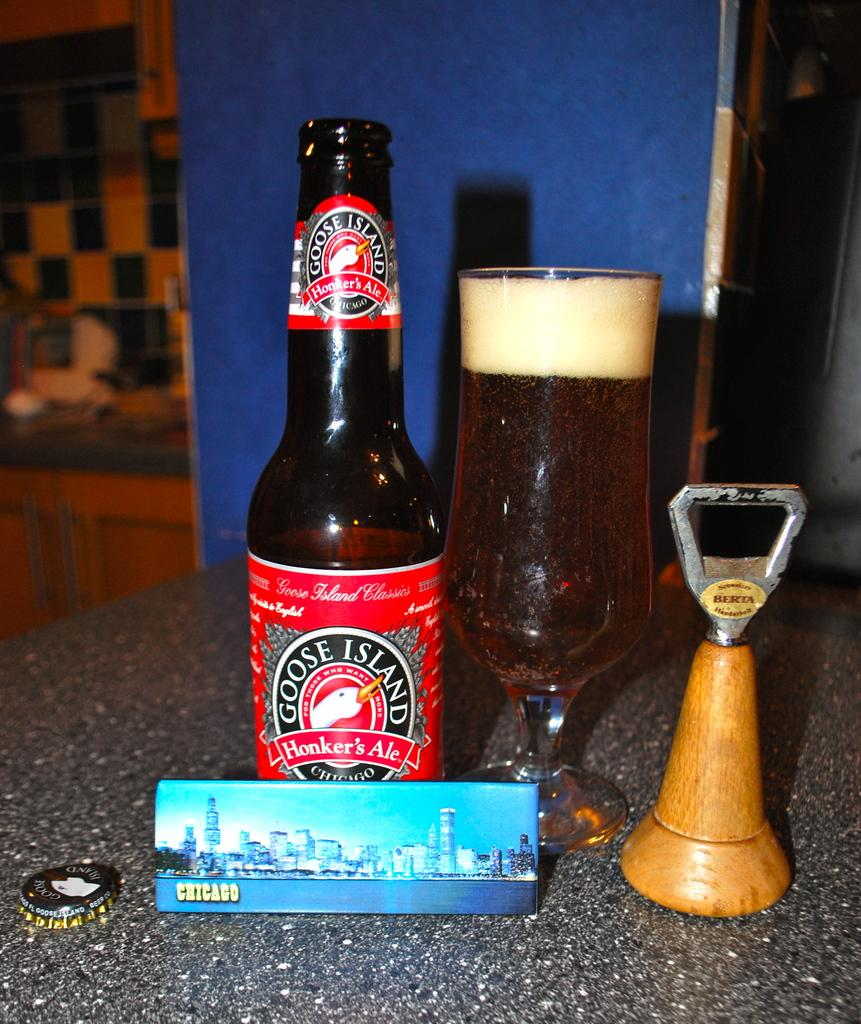<image>
Give a short and clear explanation of the subsequent image. A bottle of Goose Island ale has a red label. 